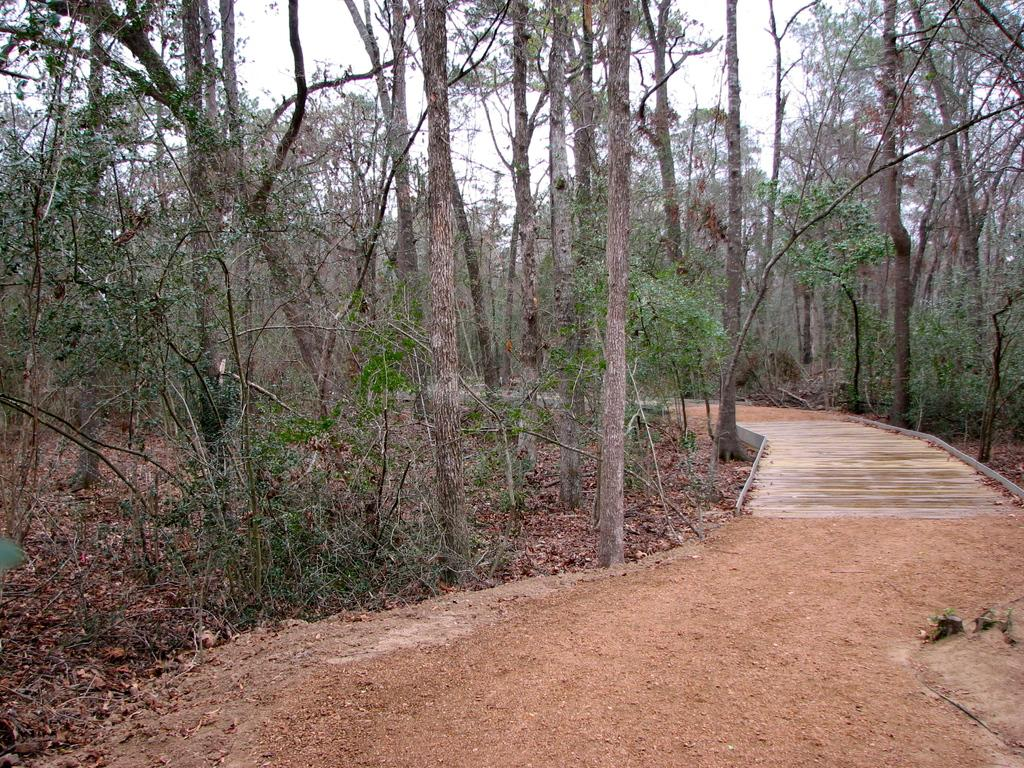What type of vegetation can be seen in the image? There are trees in the image. What can be found in the image that might be used for walking or traveling? There is a pathway in the image. What is visible in the background of the image? The sky is visible in the background of the image. Can you see any cords hanging from the trees in the image? There are no cords visible in the image; it only features trees and a pathway. What type of reading material is present in the image? There is no reading material present in the image; it only features trees, a pathway, and the sky. 